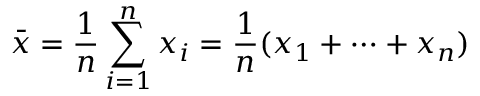<formula> <loc_0><loc_0><loc_500><loc_500>{ \bar { x } } = { \frac { 1 } { n } } \sum _ { i = 1 } ^ { n } x _ { i } = { \frac { 1 } { n } } ( x _ { 1 } + \cdots + x _ { n } )</formula> 